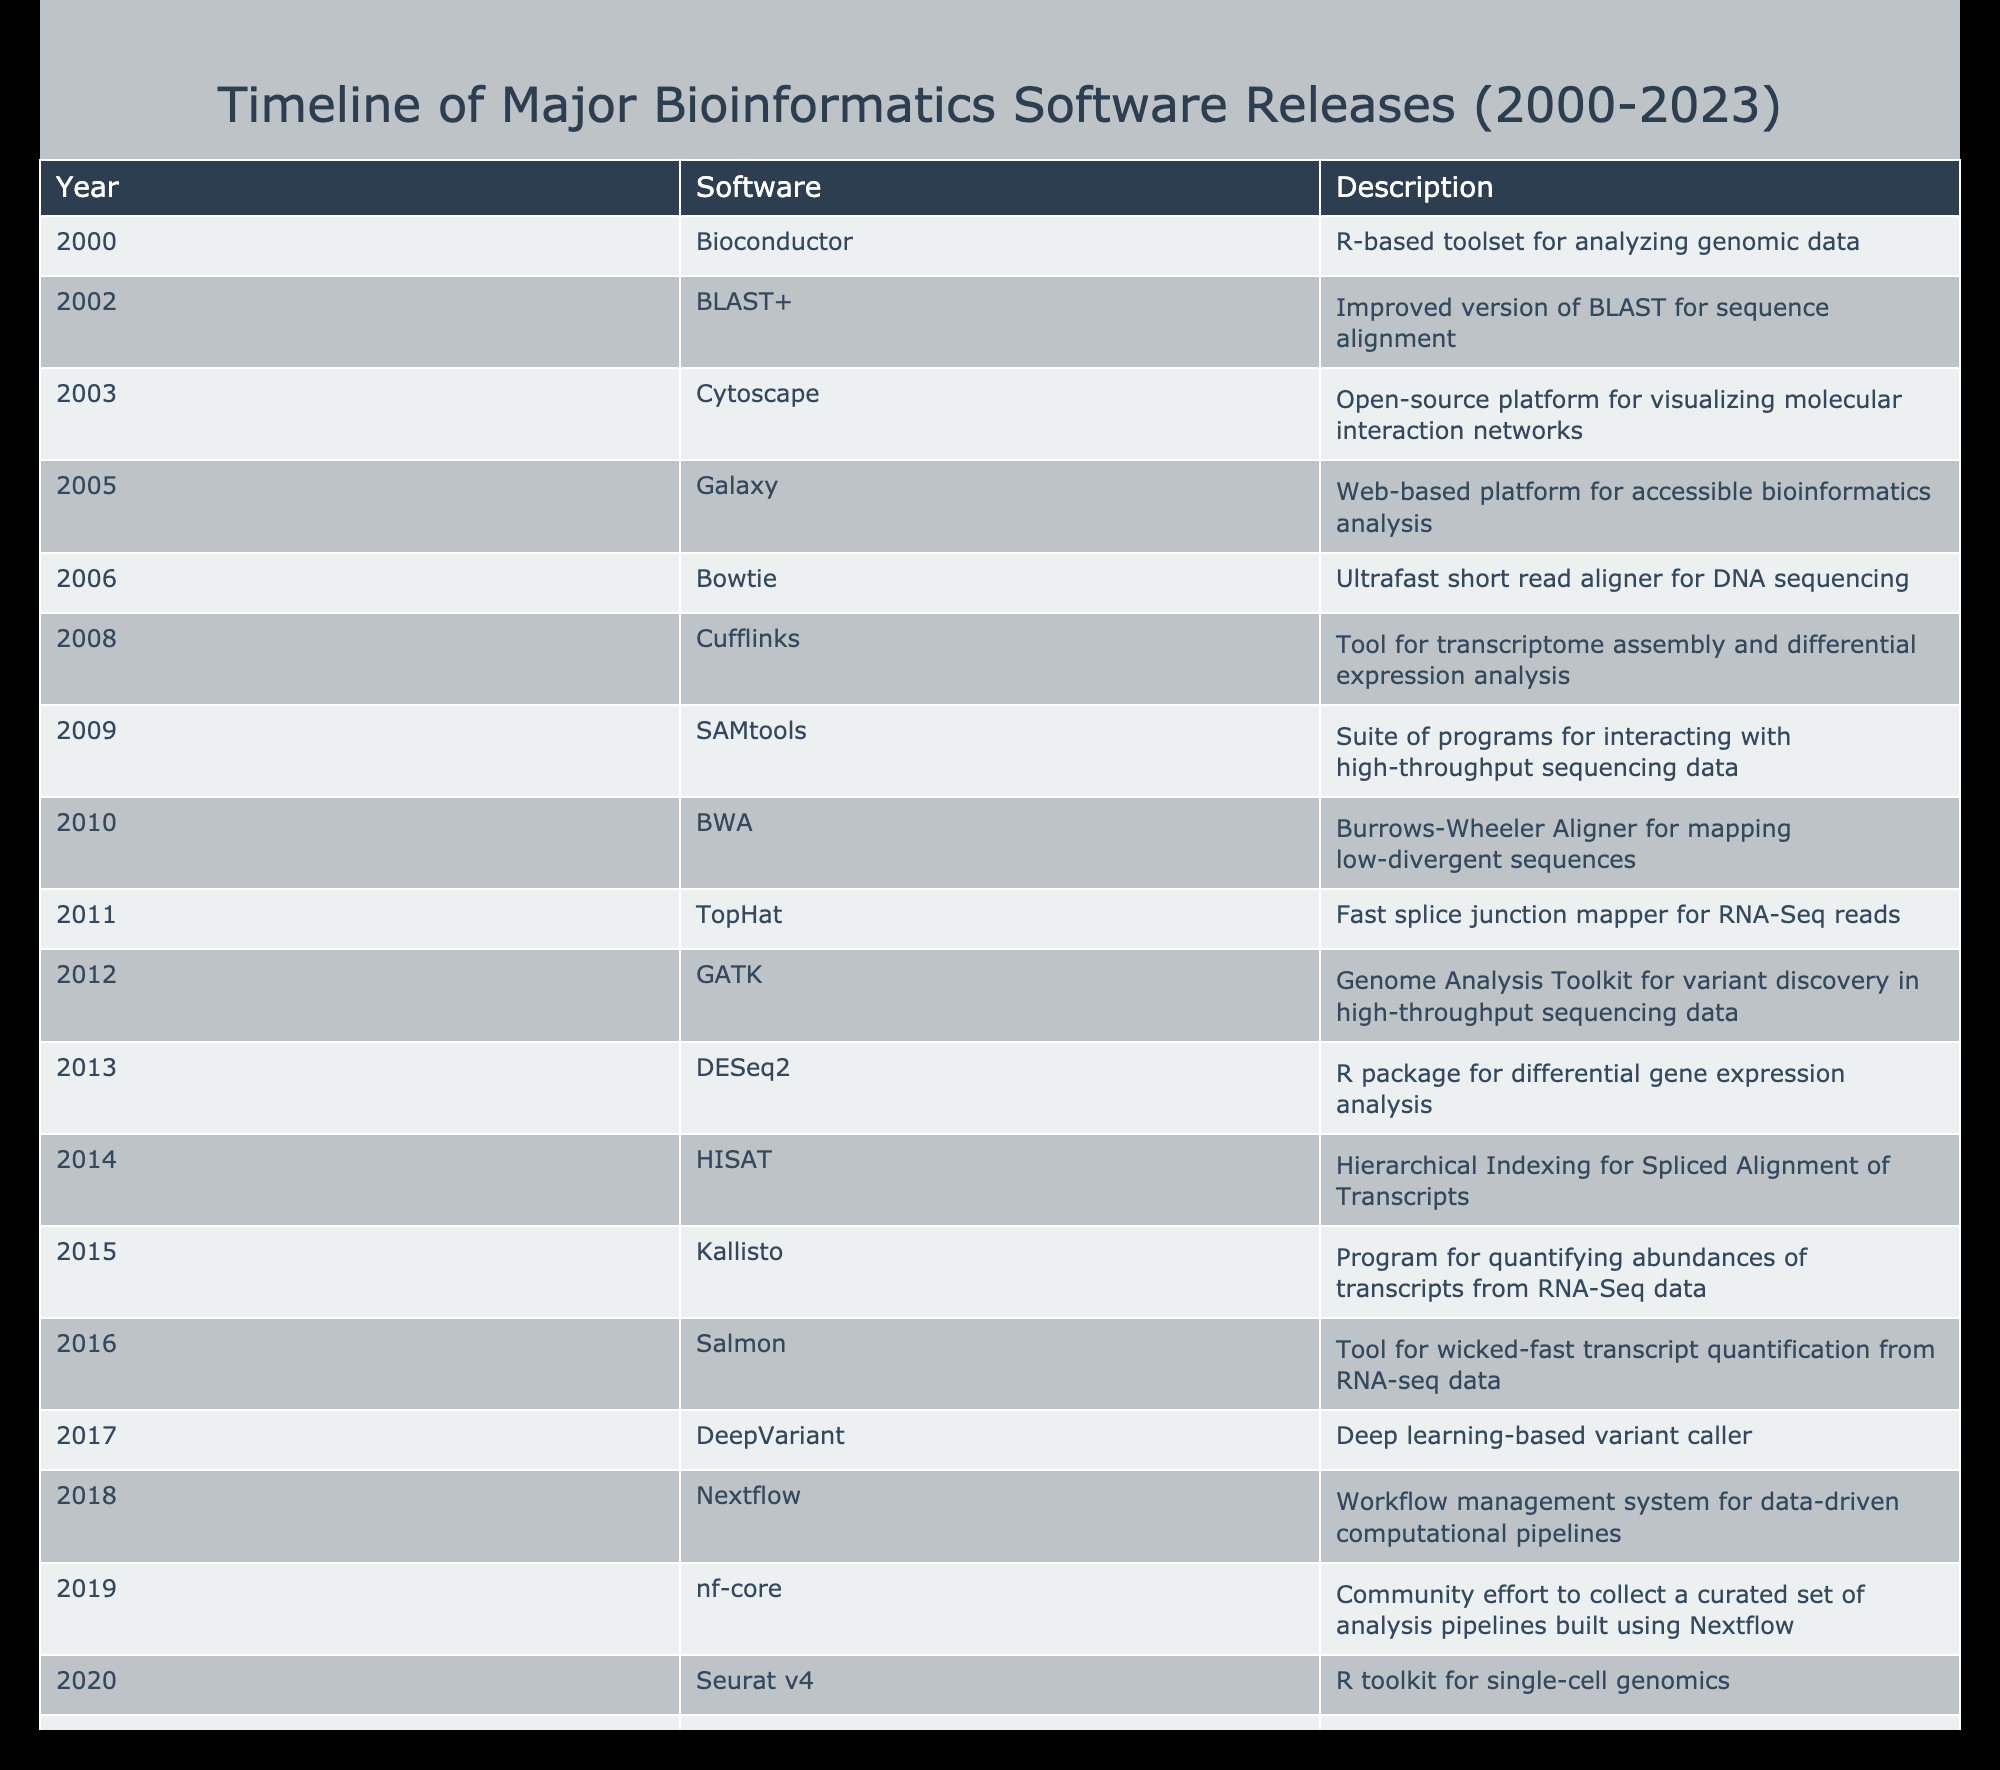What bioinformatics software was released in 2002? According to the table, the software released in 2002 is BLAST+, which is an improved version of BLAST for sequence alignment.
Answer: BLAST+ How many software releases occurred before 2010? To find the number of software releases before 2010, I count all the years from 2000 to 2009. The software released during this period are: Bioconductor (2000), BLAST+ (2002), Cytoscape (2003), Galaxy (2005), Bowtie (2006), Cufflinks (2008), SAMtools (2009). This totals to 7 releases.
Answer: 7 Was Cufflinks released after 2010? By checking the release year of Cufflinks in the table, which is 2008, and comparing it to 2010, I see that it was not released after that year.
Answer: No Which software was specifically designed for single-cell genomics? The table shows that Seurat v4, released in 2020, is an R toolkit for single-cell genomics. This clearly indicates its specific design for that area of research.
Answer: Seurat v4 What is the interval in years between the release of GATK and AlphaFold? To calculate this, I find the release year of GATK (2012) and AlphaFold (2022). The difference is 2022 - 2012 = 10 years. Thus, the interval in years between these two releases is 10.
Answer: 10 What is the latest software listed in the table, and what is its description? The latest software listed is Gromacs 2023, released in 2023. Its description states that it is a molecular dynamics package for biomolecular simulations.
Answer: Gromacs 2023, molecular dynamics package for biomolecular simulations How many software releases are related to RNA-Seq data? By reviewing the table, the software related to RNA-Seq data includes TopHat (2011), Cufflinks (2008), Kallisto (2015), and Salmon (2016). Counting these gives a total of 4 software releases related to RNA-Seq data.
Answer: 4 Is there any software released in 2019? The table shows that nf-core was released in 2019, confirming there is indeed software released in that year.
Answer: Yes 